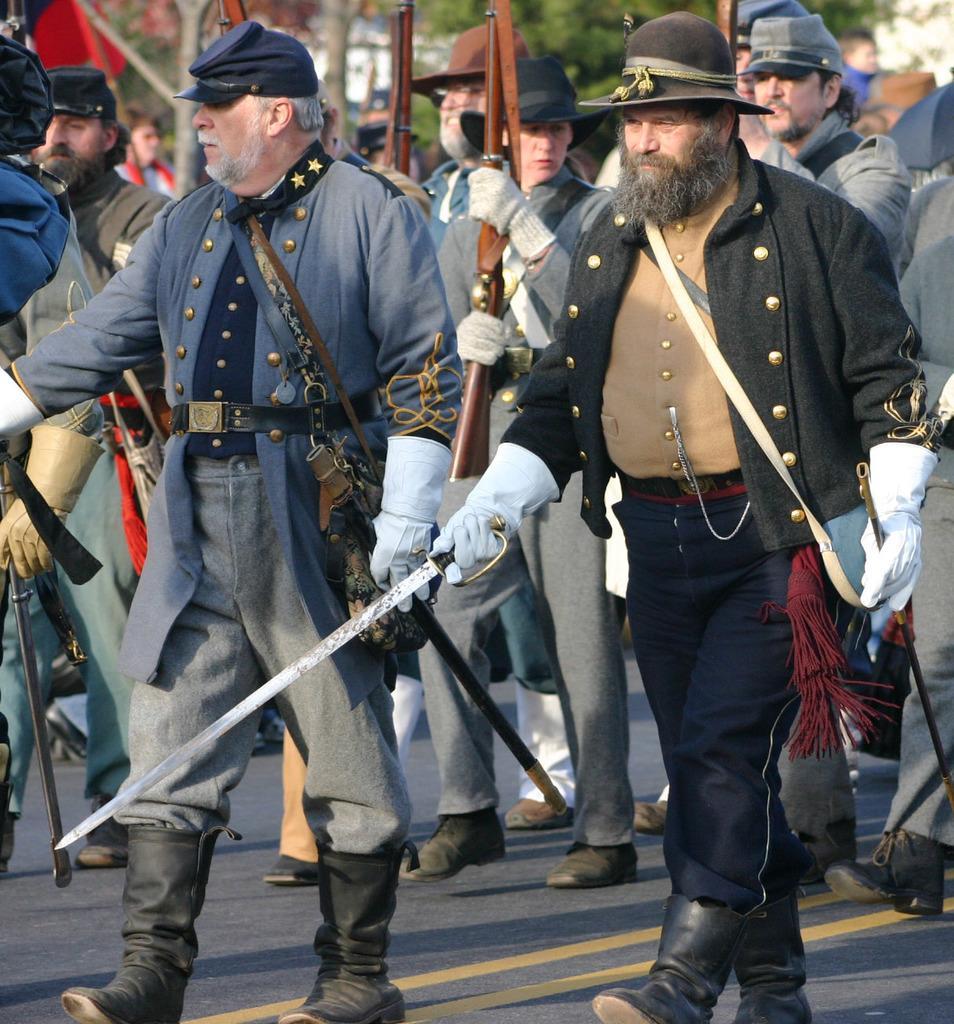Can you describe this image briefly? In this picture there are two persons standing and holding swords in their hands and there are few other persons standing behind them are holding guns in their hands and there are trees in the background. 